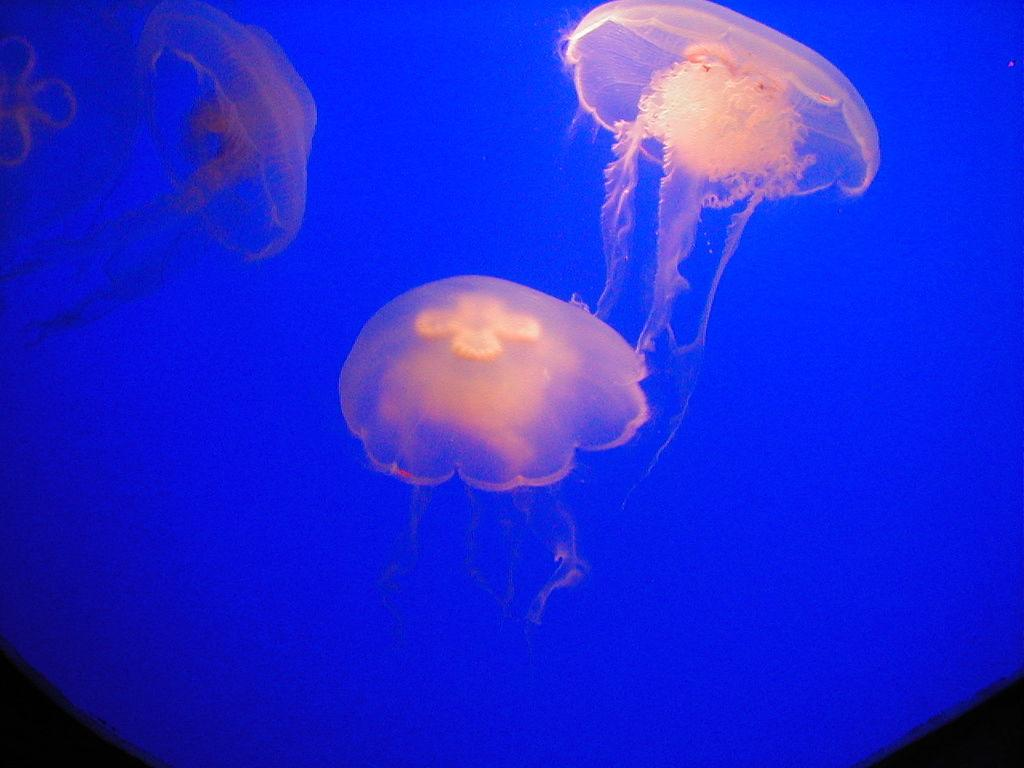What is the main subject in the center of the image? There is water in the center of the image. What creatures can be seen in the water? Jellyfishes are present in the water. What advice is the cow giving to the jellyfish in the image? There is no cow present in the image, so it is not possible to answer that question. 